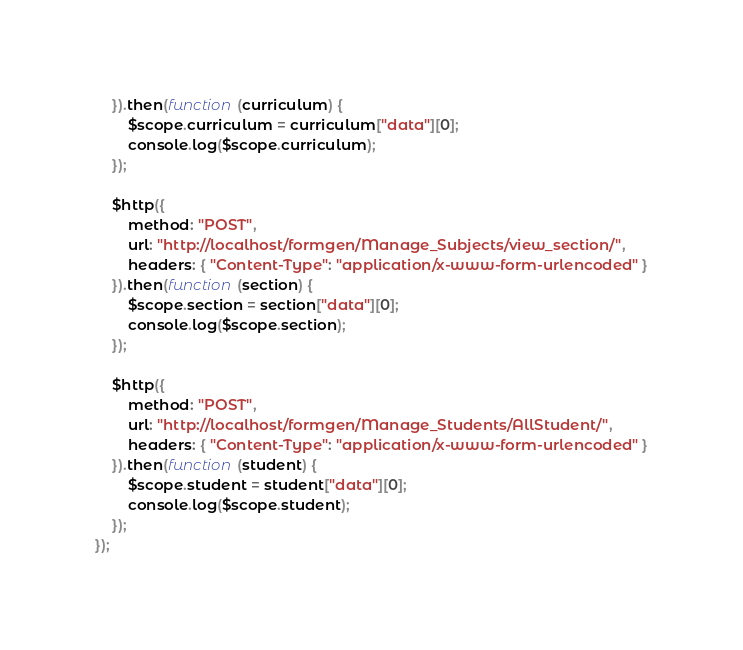<code> <loc_0><loc_0><loc_500><loc_500><_JavaScript_>	}).then(function (curriculum) {
		$scope.curriculum = curriculum["data"][0];
		console.log($scope.curriculum);
	});

	$http({
		method: "POST",
		url: "http://localhost/formgen/Manage_Subjects/view_section/",
		headers: { "Content-Type": "application/x-www-form-urlencoded" }
	}).then(function (section) {
		$scope.section = section["data"][0];
		console.log($scope.section);
	});

	$http({
		method: "POST",
		url: "http://localhost/formgen/Manage_Students/AllStudent/",
		headers: { "Content-Type": "application/x-www-form-urlencoded" }
	}).then(function (student) {
		$scope.student = student["data"][0];
		console.log($scope.student);
	});
});
</code> 